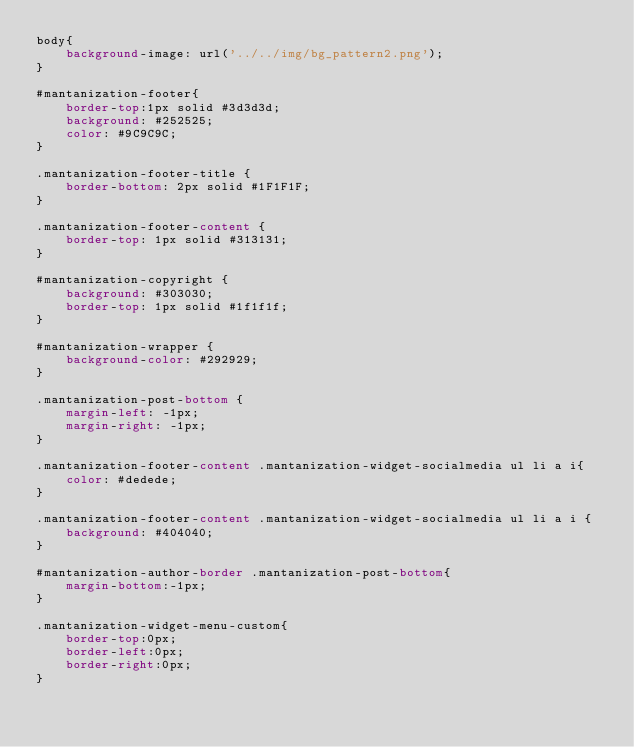<code> <loc_0><loc_0><loc_500><loc_500><_CSS_>body{
    background-image: url('../../img/bg_pattern2.png');
}

#mantanization-footer{
    border-top:1px solid #3d3d3d;
    background: #252525;
    color: #9C9C9C;
}

.mantanization-footer-title {
    border-bottom: 2px solid #1F1F1F;
}

.mantanization-footer-content {
    border-top: 1px solid #313131;
}

#mantanization-copyright {
    background: #303030;
    border-top: 1px solid #1f1f1f;
}

#mantanization-wrapper {
    background-color: #292929;
}

.mantanization-post-bottom {
    margin-left: -1px;
    margin-right: -1px;
}

.mantanization-footer-content .mantanization-widget-socialmedia ul li a i{
    color: #dedede;
}

.mantanization-footer-content .mantanization-widget-socialmedia ul li a i {
    background: #404040;
}

#mantanization-author-border .mantanization-post-bottom{
    margin-bottom:-1px;
}

.mantanization-widget-menu-custom{
    border-top:0px;
    border-left:0px;
    border-right:0px;
}</code> 